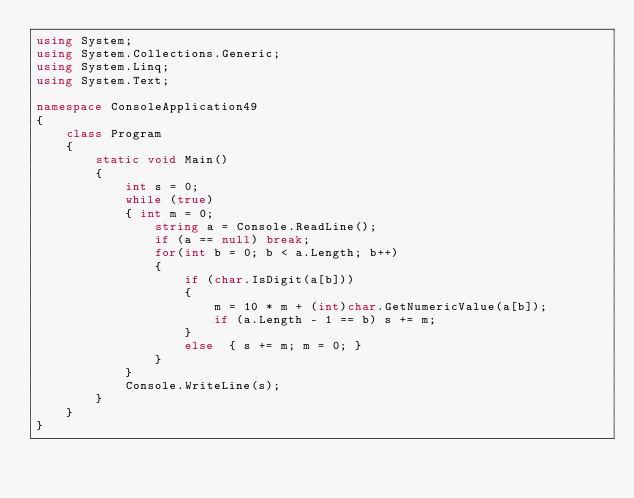<code> <loc_0><loc_0><loc_500><loc_500><_C#_>using System;
using System.Collections.Generic;
using System.Linq;
using System.Text;

namespace ConsoleApplication49
{
    class Program
    {
        static void Main()
        {
            int s = 0;
            while (true)
            { int m = 0;
                string a = Console.ReadLine();
                if (a == null) break;
                for(int b = 0; b < a.Length; b++)
                {
                    if (char.IsDigit(a[b]))
                    {
                        m = 10 * m + (int)char.GetNumericValue(a[b]);
                        if (a.Length - 1 == b) s += m;
                    }
                    else  { s += m; m = 0; }
                }
            }
            Console.WriteLine(s);
        }
    }
}</code> 